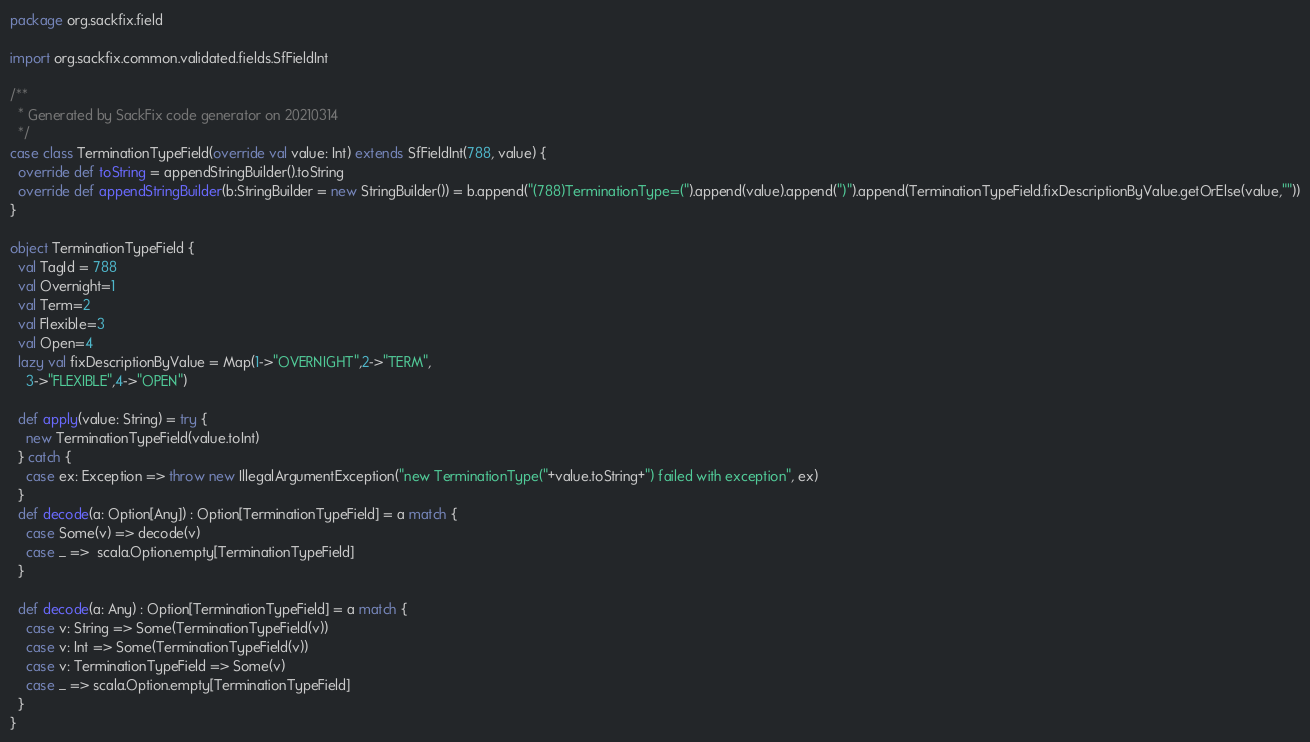<code> <loc_0><loc_0><loc_500><loc_500><_Scala_>package org.sackfix.field

import org.sackfix.common.validated.fields.SfFieldInt

/**
  * Generated by SackFix code generator on 20210314
  */
case class TerminationTypeField(override val value: Int) extends SfFieldInt(788, value) {
  override def toString = appendStringBuilder().toString
  override def appendStringBuilder(b:StringBuilder = new StringBuilder()) = b.append("(788)TerminationType=(").append(value).append(")").append(TerminationTypeField.fixDescriptionByValue.getOrElse(value,""))
}

object TerminationTypeField {
  val TagId = 788 
  val Overnight=1
  val Term=2
  val Flexible=3
  val Open=4
  lazy val fixDescriptionByValue = Map(1->"OVERNIGHT",2->"TERM",
    3->"FLEXIBLE",4->"OPEN")
 
  def apply(value: String) = try {
    new TerminationTypeField(value.toInt)
  } catch {
    case ex: Exception => throw new IllegalArgumentException("new TerminationType("+value.toString+") failed with exception", ex)
  } 
  def decode(a: Option[Any]) : Option[TerminationTypeField] = a match {
    case Some(v) => decode(v)
    case _ =>  scala.Option.empty[TerminationTypeField]
  }

  def decode(a: Any) : Option[TerminationTypeField] = a match {
    case v: String => Some(TerminationTypeField(v))
    case v: Int => Some(TerminationTypeField(v))
    case v: TerminationTypeField => Some(v)
    case _ => scala.Option.empty[TerminationTypeField]
  } 
}
</code> 